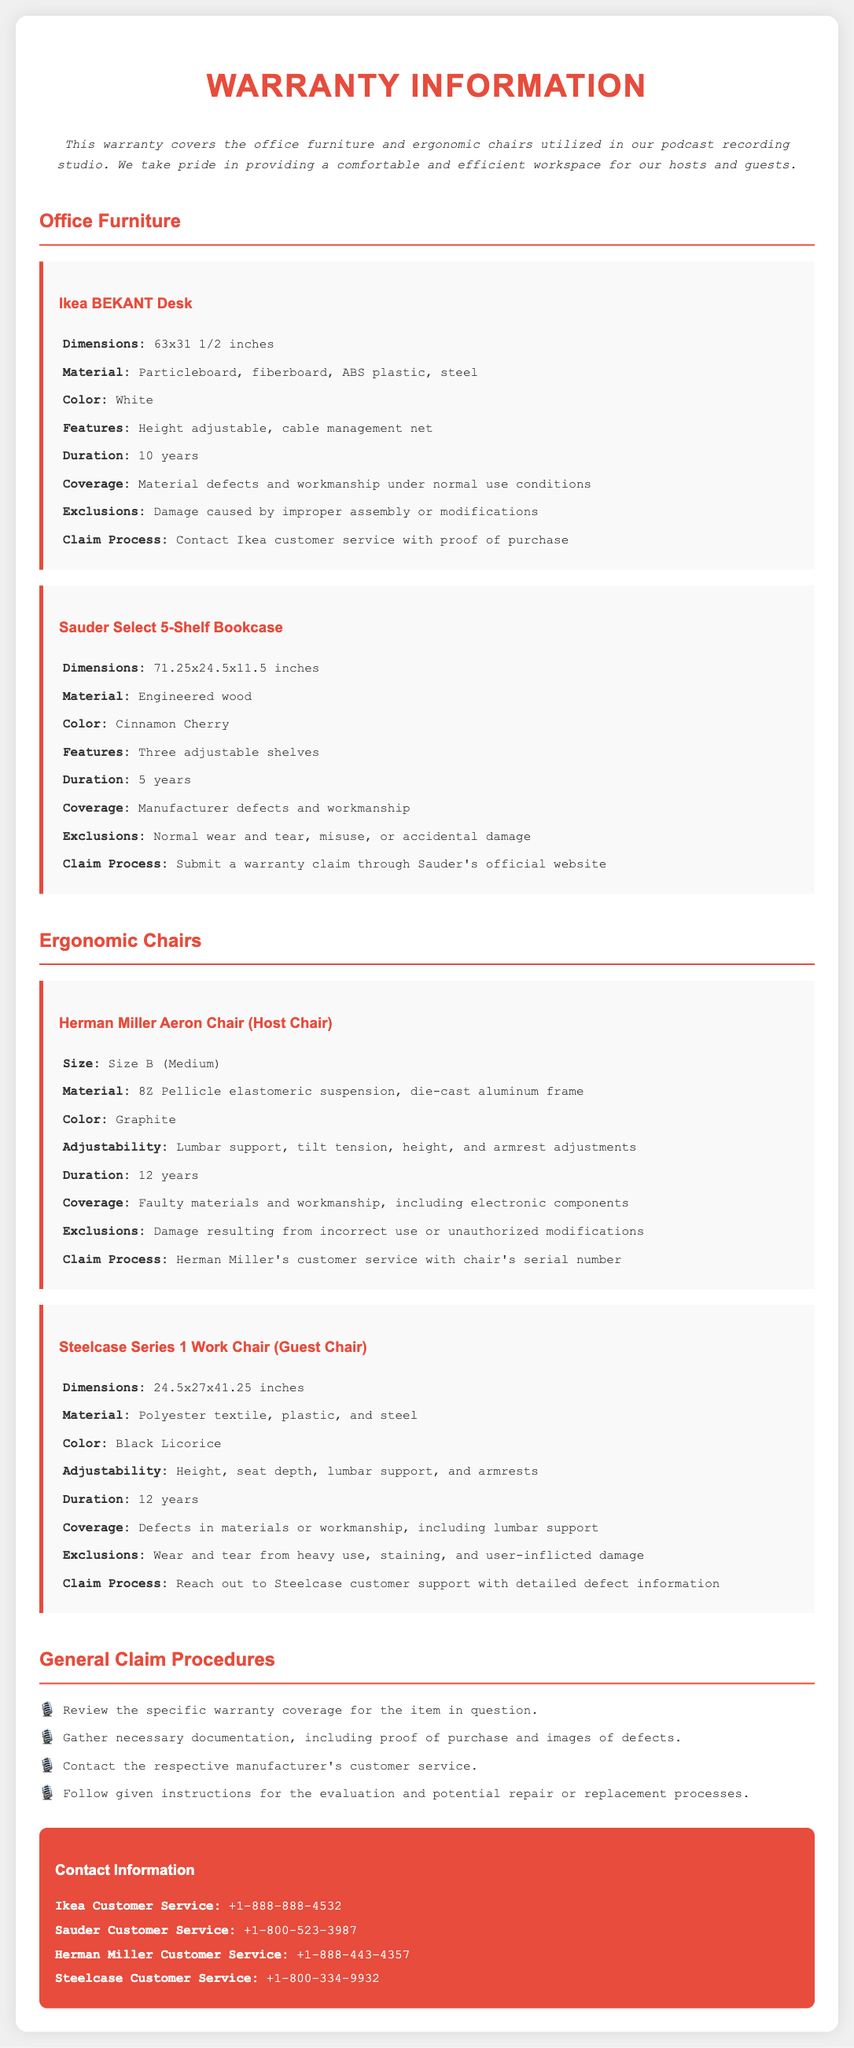What is the warranty duration for the Ikea BEKANT Desk? The warranty duration is specified in the document as 10 years.
Answer: 10 years What materials are used in the Herman Miller Aeron Chair? The materials used for the chair are listed as 8Z Pellicle elastomeric suspension and die-cast aluminum frame.
Answer: 8Z Pellicle elastomeric suspension, die-cast aluminum frame What is the size of the Steelcase Series 1 Work Chair? The document specifies the size in dimensions as 24.5x27x41.25 inches.
Answer: 24.5x27x41.25 inches What should you do if you want to claim warranty for the Sauder Select 5-Shelf Bookcase? The claim process includes submitting a warranty claim through Sauder's official website according to the information given in the document.
Answer: Submit a warranty claim through Sauder's official website What is one exclusion for the Herman Miller Aeron Chair warranty? The document states that damage resulting from incorrect use or unauthorized modifications is an exclusion.
Answer: Damage resulting from incorrect use or unauthorized modifications How many adjustable shelves does the Sauder Select 5-Shelf Bookcase have? The document mentions that the bookcase has three adjustable shelves specified in the features.
Answer: Three adjustable shelves What color is the Steelcase Series 1 Work Chair? The document lists the color as Black Licorice.
Answer: Black Licorice What is the warranty coverage for the Ikea BEKANT Desk? The coverage mentioned in the document is for material defects and workmanship under normal use conditions.
Answer: Material defects and workmanship under normal use conditions 